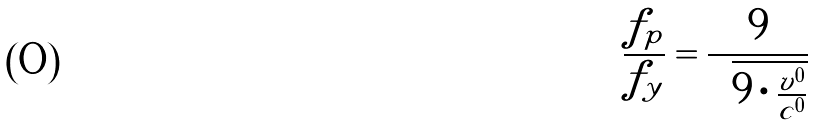<formula> <loc_0><loc_0><loc_500><loc_500>\frac { f _ { p } } { f _ { y } } = \frac { 9 } { \sqrt { 9 \cdot \frac { v ^ { 0 } } { c ^ { 0 } } } }</formula> 